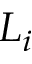<formula> <loc_0><loc_0><loc_500><loc_500>L _ { i }</formula> 